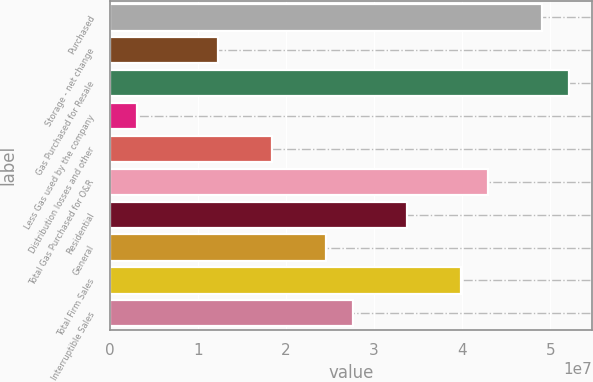<chart> <loc_0><loc_0><loc_500><loc_500><bar_chart><fcel>Purchased<fcel>Storage - net change<fcel>Gas Purchased for Resale<fcel>Less Gas used by the company<fcel>Distribution losses and other<fcel>Total Gas Purchased for O&R<fcel>Residential<fcel>General<fcel>Total Firm Sales<fcel>Interruptible Sales<nl><fcel>4.90586e+07<fcel>1.23049e+07<fcel>5.21215e+07<fcel>3.1165e+06<fcel>1.84305e+07<fcel>4.2933e+07<fcel>3.37446e+07<fcel>2.45562e+07<fcel>3.98702e+07<fcel>2.7619e+07<nl></chart> 